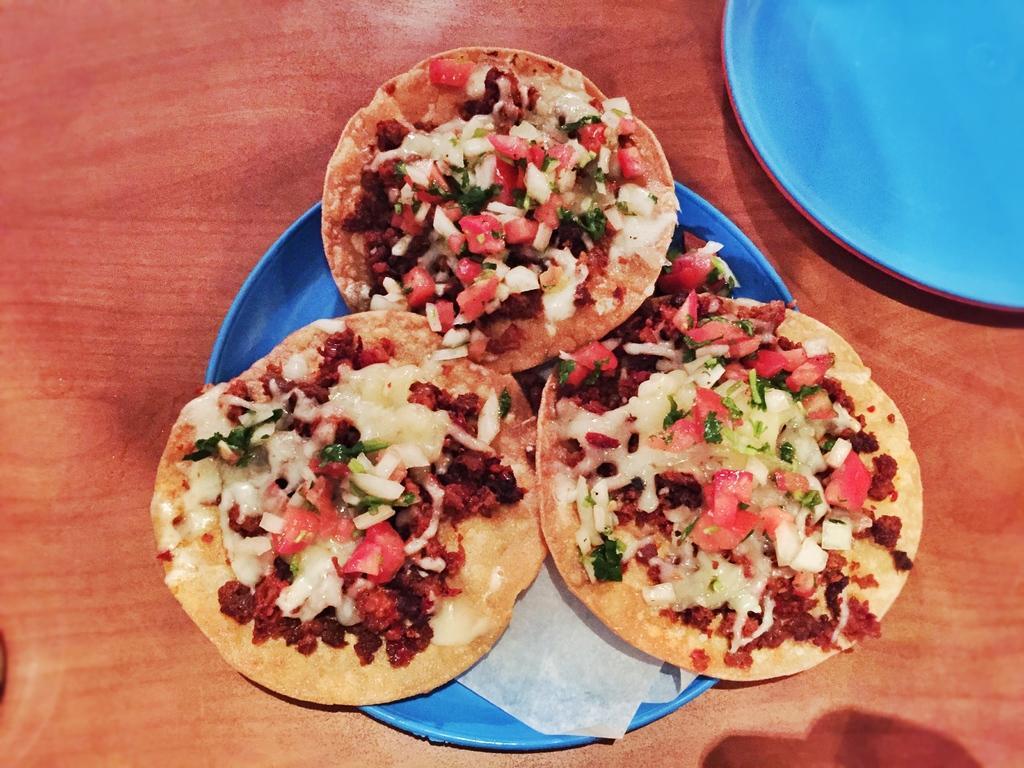Could you give a brief overview of what you see in this image? In this picture there are few eatables placed in a blue color plate and there are two other plates placed in the right top corner. 